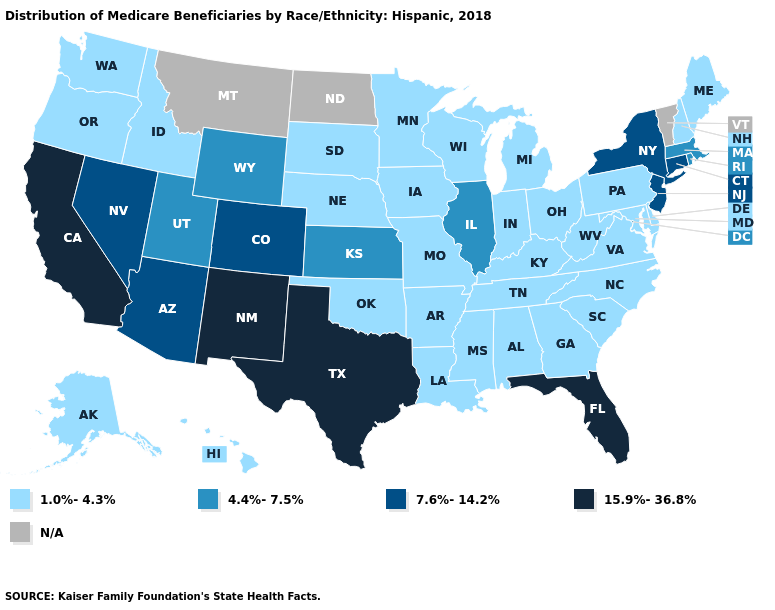Does Maine have the highest value in the Northeast?
Quick response, please. No. What is the value of New York?
Short answer required. 7.6%-14.2%. What is the value of South Dakota?
Quick response, please. 1.0%-4.3%. What is the highest value in states that border Pennsylvania?
Keep it brief. 7.6%-14.2%. What is the highest value in the USA?
Be succinct. 15.9%-36.8%. What is the value of Connecticut?
Short answer required. 7.6%-14.2%. Does Texas have the highest value in the South?
Keep it brief. Yes. What is the value of Wyoming?
Be succinct. 4.4%-7.5%. Among the states that border Indiana , does Illinois have the highest value?
Give a very brief answer. Yes. Among the states that border Pennsylvania , does New York have the highest value?
Short answer required. Yes. What is the value of Idaho?
Answer briefly. 1.0%-4.3%. What is the value of Vermont?
Concise answer only. N/A. Name the states that have a value in the range 4.4%-7.5%?
Write a very short answer. Illinois, Kansas, Massachusetts, Rhode Island, Utah, Wyoming. 